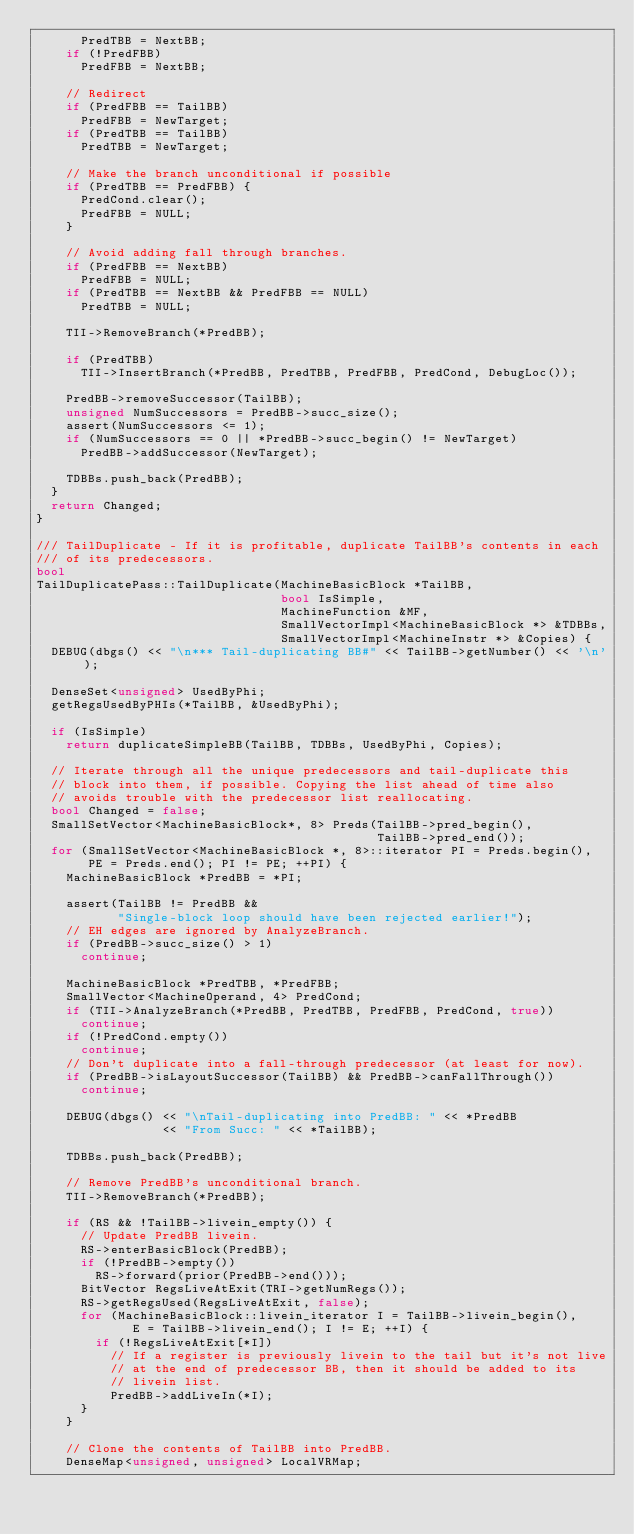Convert code to text. <code><loc_0><loc_0><loc_500><loc_500><_C++_>      PredTBB = NextBB;
    if (!PredFBB)
      PredFBB = NextBB;

    // Redirect
    if (PredFBB == TailBB)
      PredFBB = NewTarget;
    if (PredTBB == TailBB)
      PredTBB = NewTarget;

    // Make the branch unconditional if possible
    if (PredTBB == PredFBB) {
      PredCond.clear();
      PredFBB = NULL;
    }

    // Avoid adding fall through branches.
    if (PredFBB == NextBB)
      PredFBB = NULL;
    if (PredTBB == NextBB && PredFBB == NULL)
      PredTBB = NULL;

    TII->RemoveBranch(*PredBB);

    if (PredTBB)
      TII->InsertBranch(*PredBB, PredTBB, PredFBB, PredCond, DebugLoc());

    PredBB->removeSuccessor(TailBB);
    unsigned NumSuccessors = PredBB->succ_size();
    assert(NumSuccessors <= 1);
    if (NumSuccessors == 0 || *PredBB->succ_begin() != NewTarget)
      PredBB->addSuccessor(NewTarget);

    TDBBs.push_back(PredBB);
  }
  return Changed;
}

/// TailDuplicate - If it is profitable, duplicate TailBB's contents in each
/// of its predecessors.
bool
TailDuplicatePass::TailDuplicate(MachineBasicBlock *TailBB,
                                 bool IsSimple,
                                 MachineFunction &MF,
                                 SmallVectorImpl<MachineBasicBlock *> &TDBBs,
                                 SmallVectorImpl<MachineInstr *> &Copies) {
  DEBUG(dbgs() << "\n*** Tail-duplicating BB#" << TailBB->getNumber() << '\n');

  DenseSet<unsigned> UsedByPhi;
  getRegsUsedByPHIs(*TailBB, &UsedByPhi);

  if (IsSimple)
    return duplicateSimpleBB(TailBB, TDBBs, UsedByPhi, Copies);

  // Iterate through all the unique predecessors and tail-duplicate this
  // block into them, if possible. Copying the list ahead of time also
  // avoids trouble with the predecessor list reallocating.
  bool Changed = false;
  SmallSetVector<MachineBasicBlock*, 8> Preds(TailBB->pred_begin(),
                                              TailBB->pred_end());
  for (SmallSetVector<MachineBasicBlock *, 8>::iterator PI = Preds.begin(),
       PE = Preds.end(); PI != PE; ++PI) {
    MachineBasicBlock *PredBB = *PI;

    assert(TailBB != PredBB &&
           "Single-block loop should have been rejected earlier!");
    // EH edges are ignored by AnalyzeBranch.
    if (PredBB->succ_size() > 1)
      continue;

    MachineBasicBlock *PredTBB, *PredFBB;
    SmallVector<MachineOperand, 4> PredCond;
    if (TII->AnalyzeBranch(*PredBB, PredTBB, PredFBB, PredCond, true))
      continue;
    if (!PredCond.empty())
      continue;
    // Don't duplicate into a fall-through predecessor (at least for now).
    if (PredBB->isLayoutSuccessor(TailBB) && PredBB->canFallThrough())
      continue;

    DEBUG(dbgs() << "\nTail-duplicating into PredBB: " << *PredBB
                 << "From Succ: " << *TailBB);

    TDBBs.push_back(PredBB);

    // Remove PredBB's unconditional branch.
    TII->RemoveBranch(*PredBB);

    if (RS && !TailBB->livein_empty()) {
      // Update PredBB livein.
      RS->enterBasicBlock(PredBB);
      if (!PredBB->empty())
        RS->forward(prior(PredBB->end()));
      BitVector RegsLiveAtExit(TRI->getNumRegs());
      RS->getRegsUsed(RegsLiveAtExit, false);
      for (MachineBasicBlock::livein_iterator I = TailBB->livein_begin(),
             E = TailBB->livein_end(); I != E; ++I) {
        if (!RegsLiveAtExit[*I])
          // If a register is previously livein to the tail but it's not live
          // at the end of predecessor BB, then it should be added to its
          // livein list.
          PredBB->addLiveIn(*I);
      }
    }

    // Clone the contents of TailBB into PredBB.
    DenseMap<unsigned, unsigned> LocalVRMap;</code> 